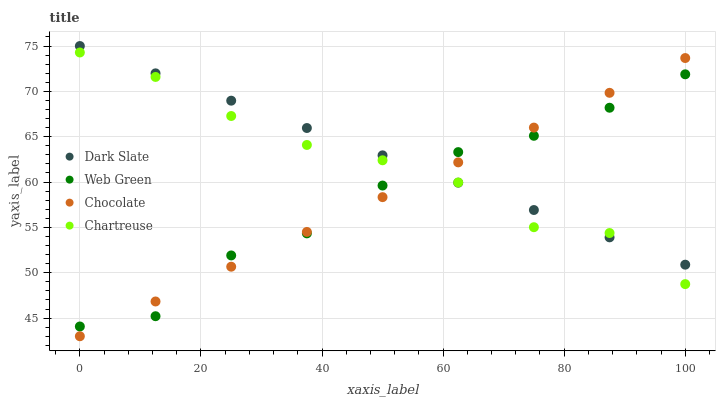Does Web Green have the minimum area under the curve?
Answer yes or no. Yes. Does Dark Slate have the maximum area under the curve?
Answer yes or no. Yes. Does Chartreuse have the minimum area under the curve?
Answer yes or no. No. Does Chartreuse have the maximum area under the curve?
Answer yes or no. No. Is Chocolate the smoothest?
Answer yes or no. Yes. Is Web Green the roughest?
Answer yes or no. Yes. Is Chartreuse the smoothest?
Answer yes or no. No. Is Chartreuse the roughest?
Answer yes or no. No. Does Chocolate have the lowest value?
Answer yes or no. Yes. Does Chartreuse have the lowest value?
Answer yes or no. No. Does Dark Slate have the highest value?
Answer yes or no. Yes. Does Chartreuse have the highest value?
Answer yes or no. No. Does Web Green intersect Chocolate?
Answer yes or no. Yes. Is Web Green less than Chocolate?
Answer yes or no. No. Is Web Green greater than Chocolate?
Answer yes or no. No. 